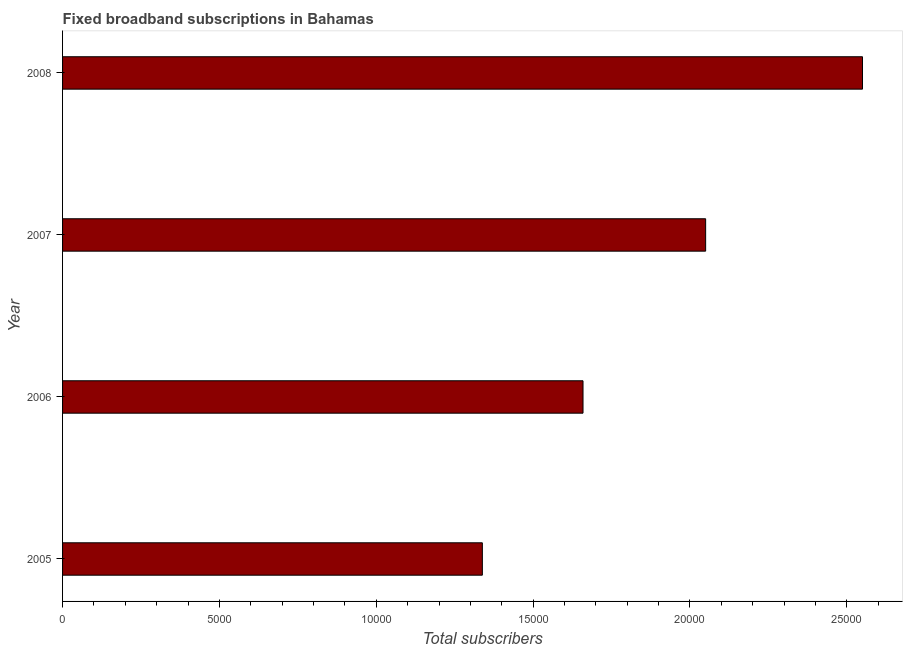Does the graph contain any zero values?
Give a very brief answer. No. Does the graph contain grids?
Give a very brief answer. No. What is the title of the graph?
Your answer should be compact. Fixed broadband subscriptions in Bahamas. What is the label or title of the X-axis?
Your answer should be compact. Total subscribers. What is the total number of fixed broadband subscriptions in 2005?
Your answer should be compact. 1.34e+04. Across all years, what is the maximum total number of fixed broadband subscriptions?
Give a very brief answer. 2.55e+04. Across all years, what is the minimum total number of fixed broadband subscriptions?
Your answer should be compact. 1.34e+04. What is the sum of the total number of fixed broadband subscriptions?
Your answer should be compact. 7.60e+04. What is the difference between the total number of fixed broadband subscriptions in 2006 and 2008?
Make the answer very short. -8909. What is the average total number of fixed broadband subscriptions per year?
Keep it short and to the point. 1.90e+04. What is the median total number of fixed broadband subscriptions?
Keep it short and to the point. 1.85e+04. In how many years, is the total number of fixed broadband subscriptions greater than 24000 ?
Offer a very short reply. 1. Do a majority of the years between 2008 and 2005 (inclusive) have total number of fixed broadband subscriptions greater than 18000 ?
Ensure brevity in your answer.  Yes. What is the ratio of the total number of fixed broadband subscriptions in 2005 to that in 2008?
Keep it short and to the point. 0.53. Is the total number of fixed broadband subscriptions in 2006 less than that in 2007?
Make the answer very short. Yes. Is the sum of the total number of fixed broadband subscriptions in 2007 and 2008 greater than the maximum total number of fixed broadband subscriptions across all years?
Your answer should be very brief. Yes. What is the difference between the highest and the lowest total number of fixed broadband subscriptions?
Your answer should be compact. 1.21e+04. How many bars are there?
Give a very brief answer. 4. Are all the bars in the graph horizontal?
Provide a short and direct response. Yes. How many years are there in the graph?
Give a very brief answer. 4. What is the difference between two consecutive major ticks on the X-axis?
Make the answer very short. 5000. Are the values on the major ticks of X-axis written in scientific E-notation?
Your answer should be compact. No. What is the Total subscribers in 2005?
Keep it short and to the point. 1.34e+04. What is the Total subscribers of 2006?
Keep it short and to the point. 1.66e+04. What is the Total subscribers in 2007?
Your answer should be very brief. 2.05e+04. What is the Total subscribers of 2008?
Give a very brief answer. 2.55e+04. What is the difference between the Total subscribers in 2005 and 2006?
Give a very brief answer. -3209. What is the difference between the Total subscribers in 2005 and 2007?
Your response must be concise. -7118. What is the difference between the Total subscribers in 2005 and 2008?
Offer a terse response. -1.21e+04. What is the difference between the Total subscribers in 2006 and 2007?
Your answer should be very brief. -3909. What is the difference between the Total subscribers in 2006 and 2008?
Your answer should be compact. -8909. What is the difference between the Total subscribers in 2007 and 2008?
Provide a short and direct response. -5000. What is the ratio of the Total subscribers in 2005 to that in 2006?
Ensure brevity in your answer.  0.81. What is the ratio of the Total subscribers in 2005 to that in 2007?
Ensure brevity in your answer.  0.65. What is the ratio of the Total subscribers in 2005 to that in 2008?
Your response must be concise. 0.53. What is the ratio of the Total subscribers in 2006 to that in 2007?
Offer a terse response. 0.81. What is the ratio of the Total subscribers in 2006 to that in 2008?
Your answer should be compact. 0.65. What is the ratio of the Total subscribers in 2007 to that in 2008?
Keep it short and to the point. 0.8. 